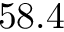<formula> <loc_0><loc_0><loc_500><loc_500>5 8 . 4</formula> 